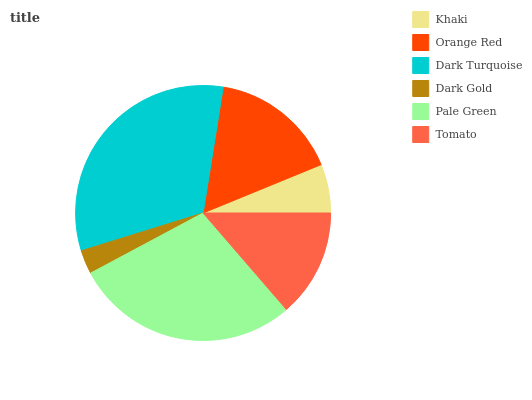Is Dark Gold the minimum?
Answer yes or no. Yes. Is Dark Turquoise the maximum?
Answer yes or no. Yes. Is Orange Red the minimum?
Answer yes or no. No. Is Orange Red the maximum?
Answer yes or no. No. Is Orange Red greater than Khaki?
Answer yes or no. Yes. Is Khaki less than Orange Red?
Answer yes or no. Yes. Is Khaki greater than Orange Red?
Answer yes or no. No. Is Orange Red less than Khaki?
Answer yes or no. No. Is Orange Red the high median?
Answer yes or no. Yes. Is Tomato the low median?
Answer yes or no. Yes. Is Pale Green the high median?
Answer yes or no. No. Is Pale Green the low median?
Answer yes or no. No. 